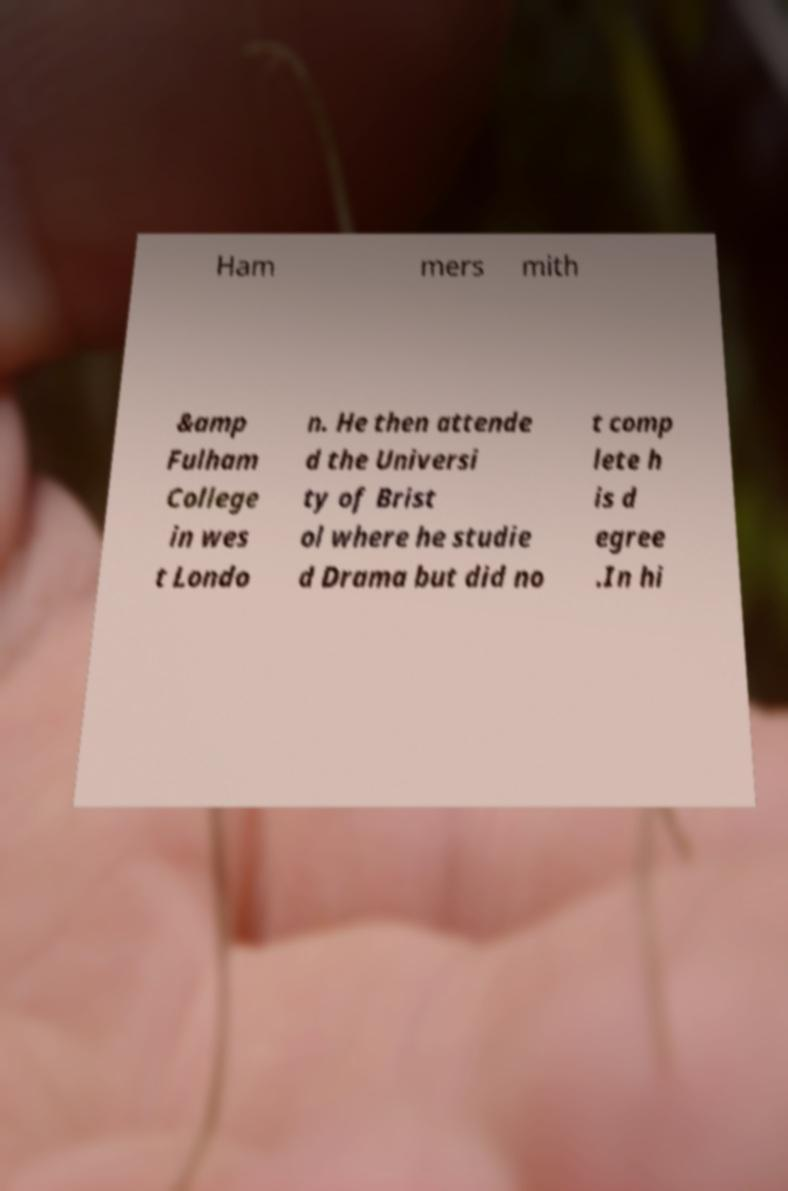Please identify and transcribe the text found in this image. Ham mers mith &amp Fulham College in wes t Londo n. He then attende d the Universi ty of Brist ol where he studie d Drama but did no t comp lete h is d egree .In hi 